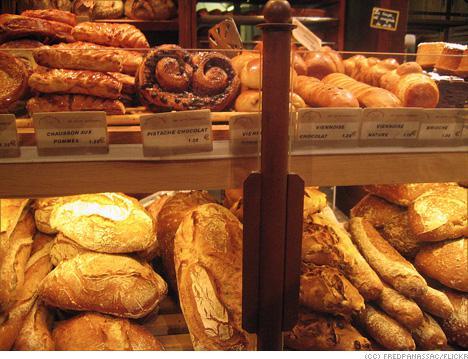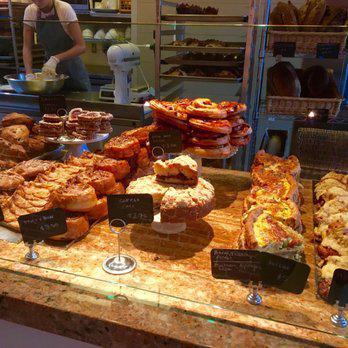The first image is the image on the left, the second image is the image on the right. Considering the images on both sides, is "The pastries in the right image are labeled, and the ones in the left image are not." valid? Answer yes or no. No. The first image is the image on the left, the second image is the image on the right. Given the left and right images, does the statement "One image shows individual stands holding cards in front of bakery items laid out on counter." hold true? Answer yes or no. Yes. 